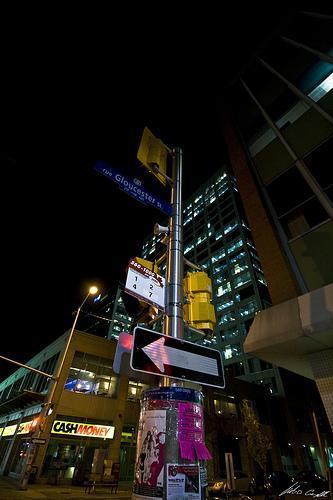How many arrows are there?
Give a very brief answer. 1. 